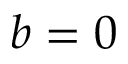Convert formula to latex. <formula><loc_0><loc_0><loc_500><loc_500>b = 0</formula> 